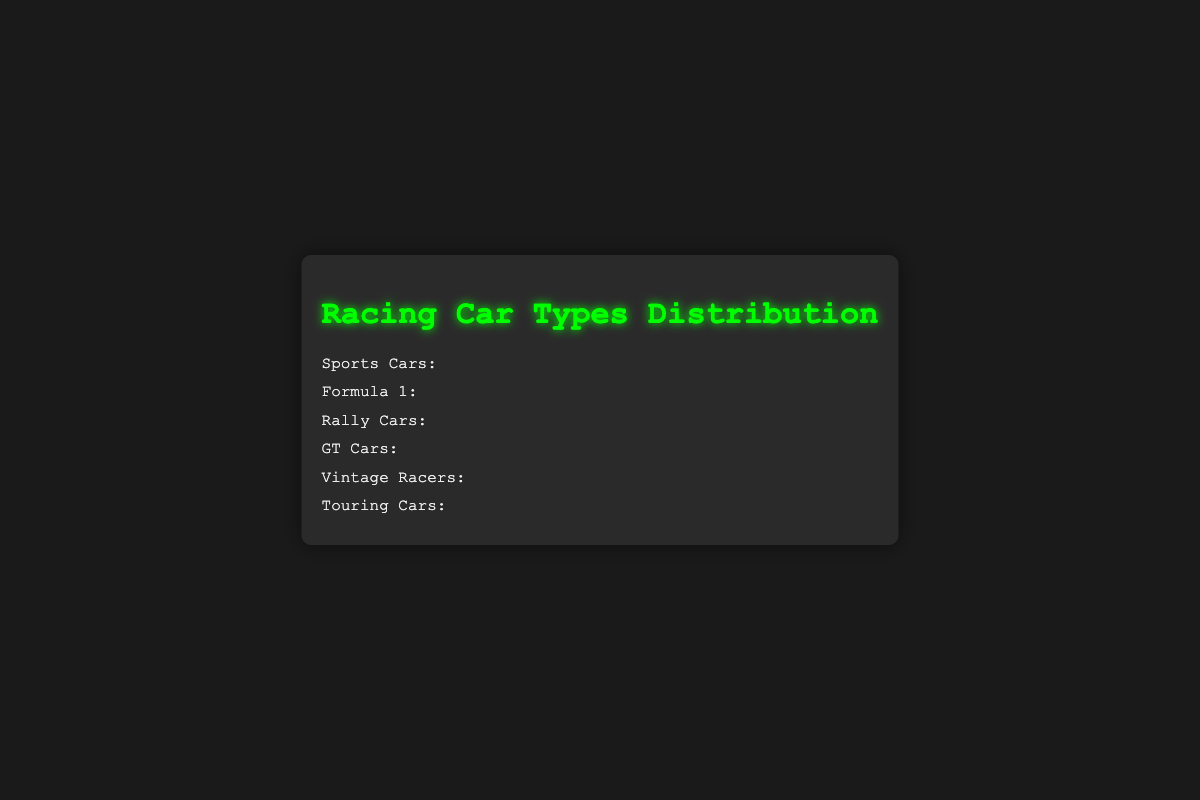What's the title of the figure? The title is usually found at the top of the figure. In this case, it's clearly written as "Racing Car Types Distribution".
Answer: Racing Car Types Distribution Which car type has the highest count? The count for each car type is represented by the number of car icons. Sports Cars have the most car icons, at 25.
Answer: Sports Cars How many car icons represent Vintage Racers? Each car icon represents one car, and there are 12 car icons under Vintage Racers.
Answer: 12 Which car type has the fewest icons? Touring Cars have the fewest car icons, with a count of 10.
Answer: Touring Cars By how many cars do Sports Cars exceed Formula 1 cars? Sports Cars have 25 cars, Formula 1 has 20 cars. The difference is 25 - 20.
Answer: 5 What's the total number of car icons for GT Cars and Rally Cars combined? GT Cars have 18 icons and Rally Cars have 15. Their total combined is 18 + 15.
Answer: 33 Compare the counts of Vintage Racers and Touring Cars. Which has more and by how much? Vintage Racers have 12 icons and Touring Cars have 10. Vintage Racers have 2 more icons than Touring Cars.
Answer: Vintage Racers by 2 Which car type has the closest count to Rally Cars but is still higher? GT Cars have 18 icons, which is higher than Rally Cars with 15 but close to it.
Answer: GT Cars If you combine the counts of Sports Cars, Formula 1, and Touring Cars, what is the total? The counts are 25 (Sports Cars) + 20 (Formula 1) + 10 (Touring Cars). Adding them gives 25 + 20 + 10.
Answer: 55 What color is used for the car icons and title? The car icons and title are colored green, specifically a bright neon green.
Answer: Green 